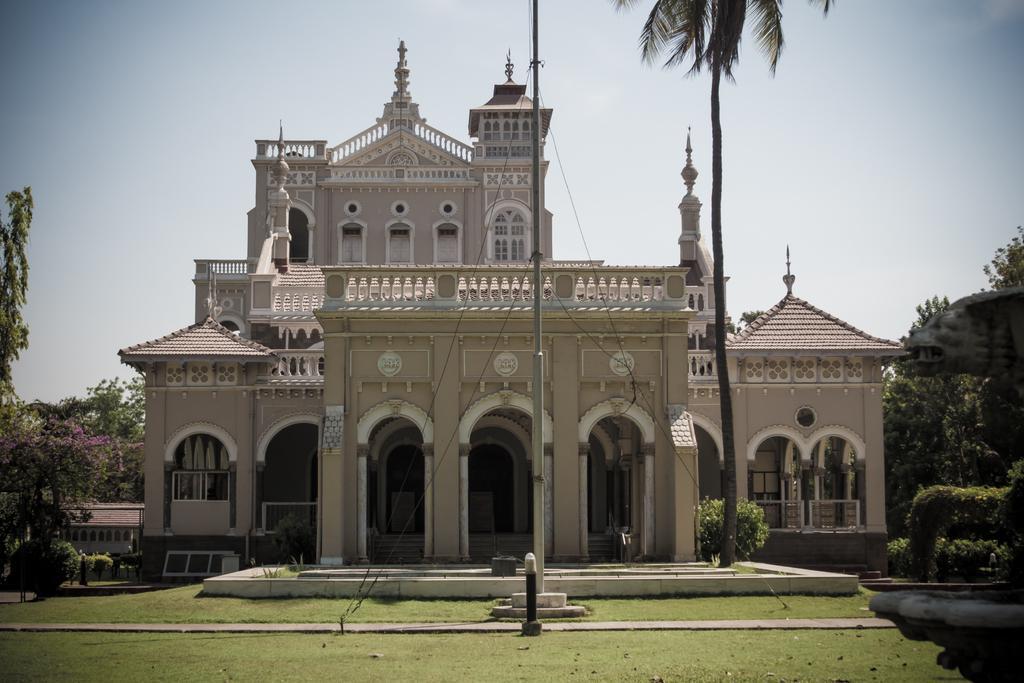In one or two sentences, can you explain what this image depicts? In this picture we can see the grass, building, trees, pole and in the background we can see the sky. 